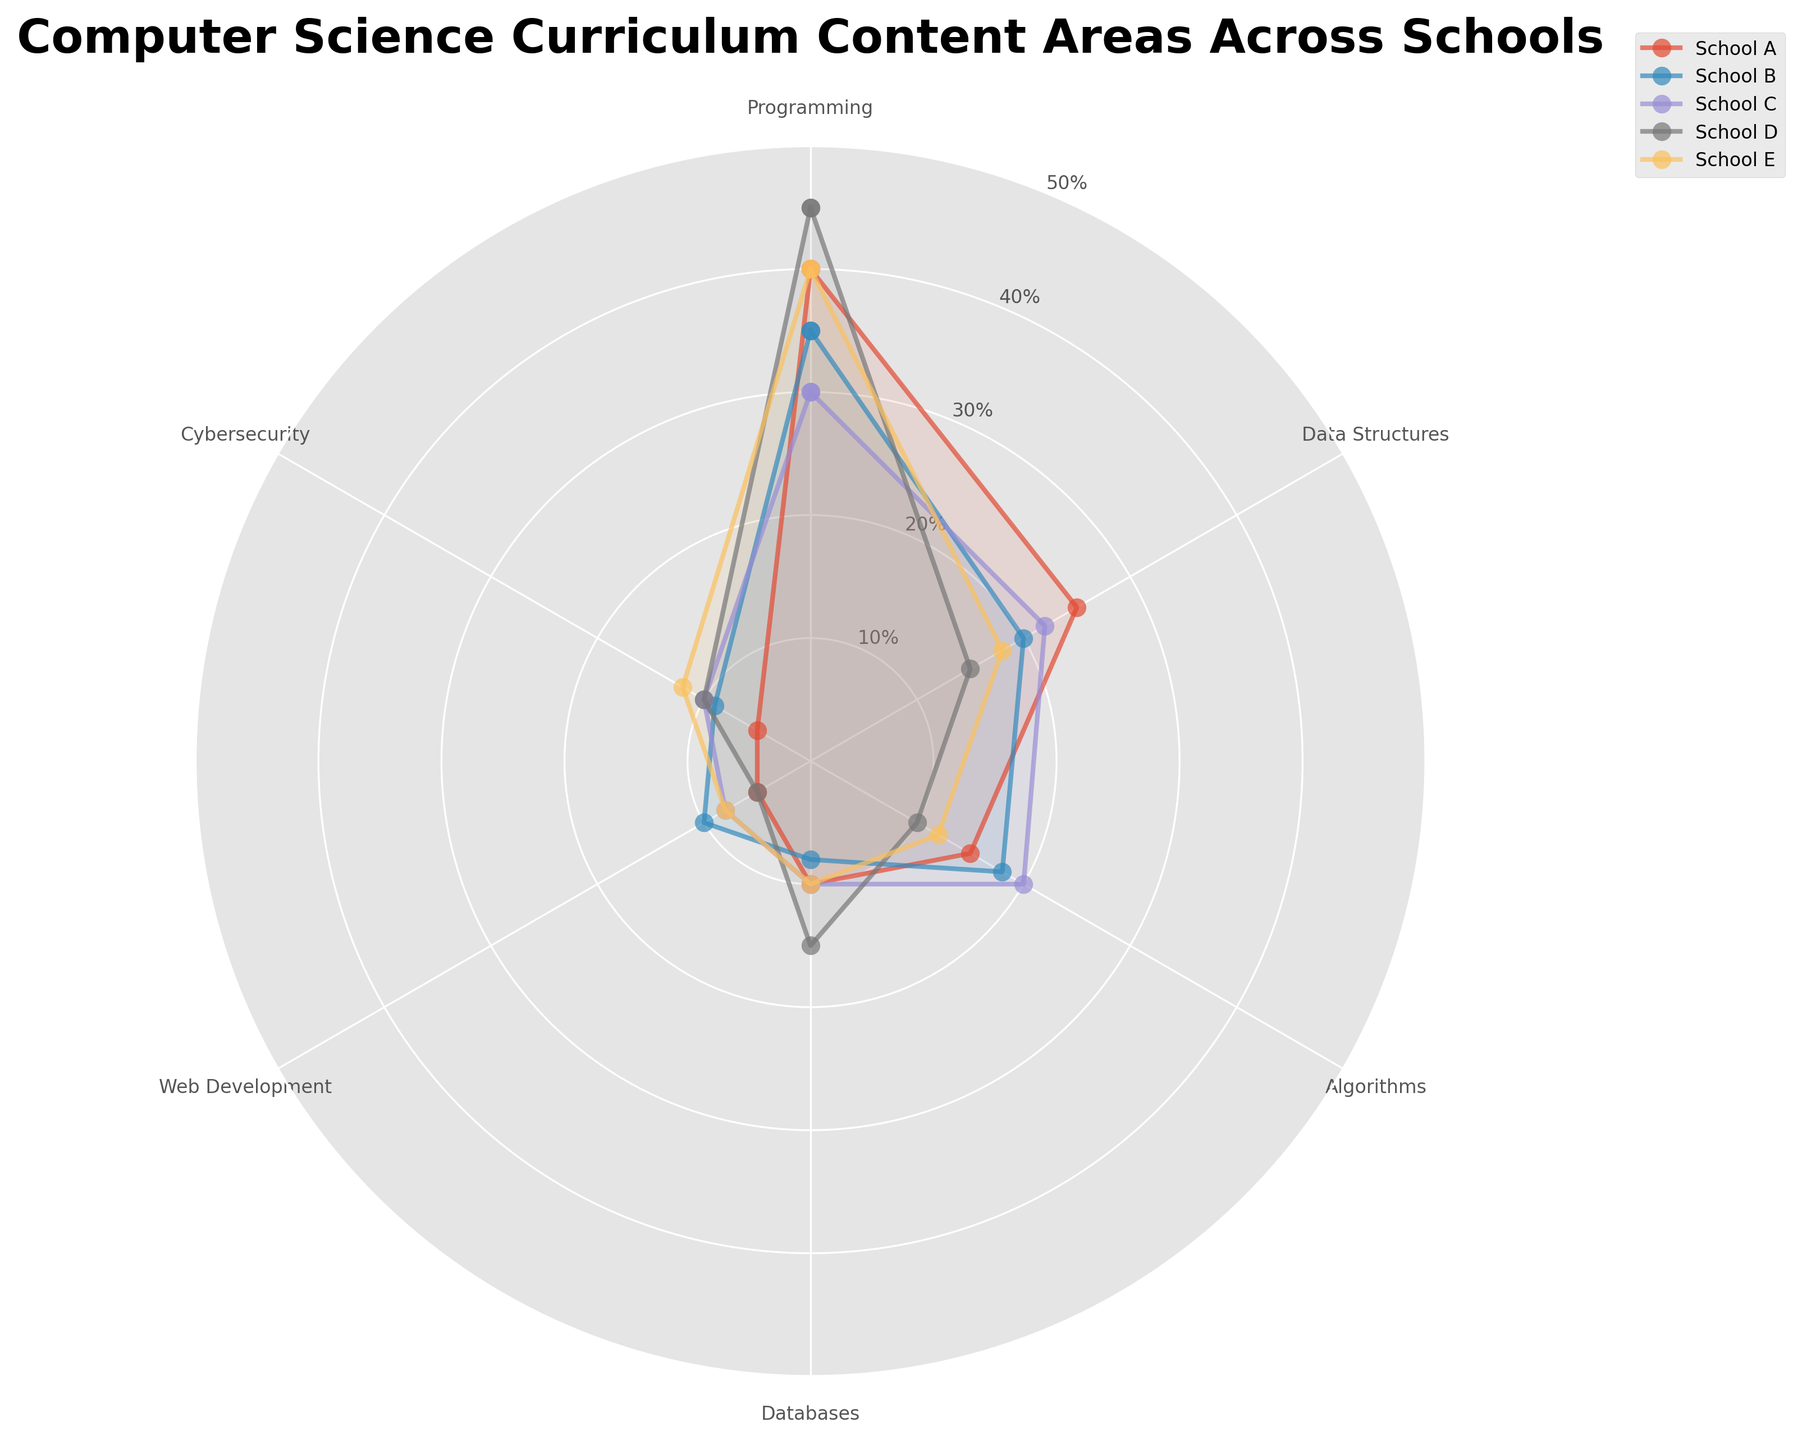What content area has the highest percentage among all schools? By inspecting the radar chart, find the segment that extends furthest from the center, indicating the highest percentage. Based on the data provided, "Programming" has the highest percentage in multiple schools.
Answer: Programming Which school covers Cybersecurity the least? Check the values associated with Cybersecurity for all schools and identify the school with the smallest value. School A has 5%, which is the lowest among all schools.
Answer: School A What is the sum of Data Structures percentages across all schools? Add up the percentages of Data Structures for School A (25), School B (20), School C (22), School D (15), and School E (18). The total is 25 + 20 + 22 + 15 + 18 = 100.
Answer: 100 Compare the percentages of Web Development and Databases in School B. Which one is higher and by how much? Check the values for Web Development (10%) and Databases (8%) in School B. Subtract the smaller percentage from the larger one. 10% - 8% = 2%. Web Development is higher by 2%.
Answer: Web Development by 2% What is the average percentage for Algorithms across all schools? Add the percentages for Algorithms from School A (15), School B (18), School C (20), School D (10), and School E (12). Then, divide the total by the number of schools: (15 + 18 + 20 + 10 + 12) / 5 = 75 / 5 = 15.
Answer: 15 Which school has the most balanced distribution across all content areas? Look for the school whose radar plot has the most regular, even shape, indicating a balanced distribution. School E has close percentages across all areas compared to others.
Answer: School E How do the percentages for Cybersecurity in School C and School E compare? Identify the Cybersecurity percentages for both schools: School C (10%) and School E (12%). School E has a higher percentage by 2%.
Answer: School E is higher by 2% If you add the percentages of Programming and Web Development in School D, what is the total? Sum the percentages for Programming (45%) and Web Development (5%) in School D. 45 + 5 = 50.
Answer: 50 